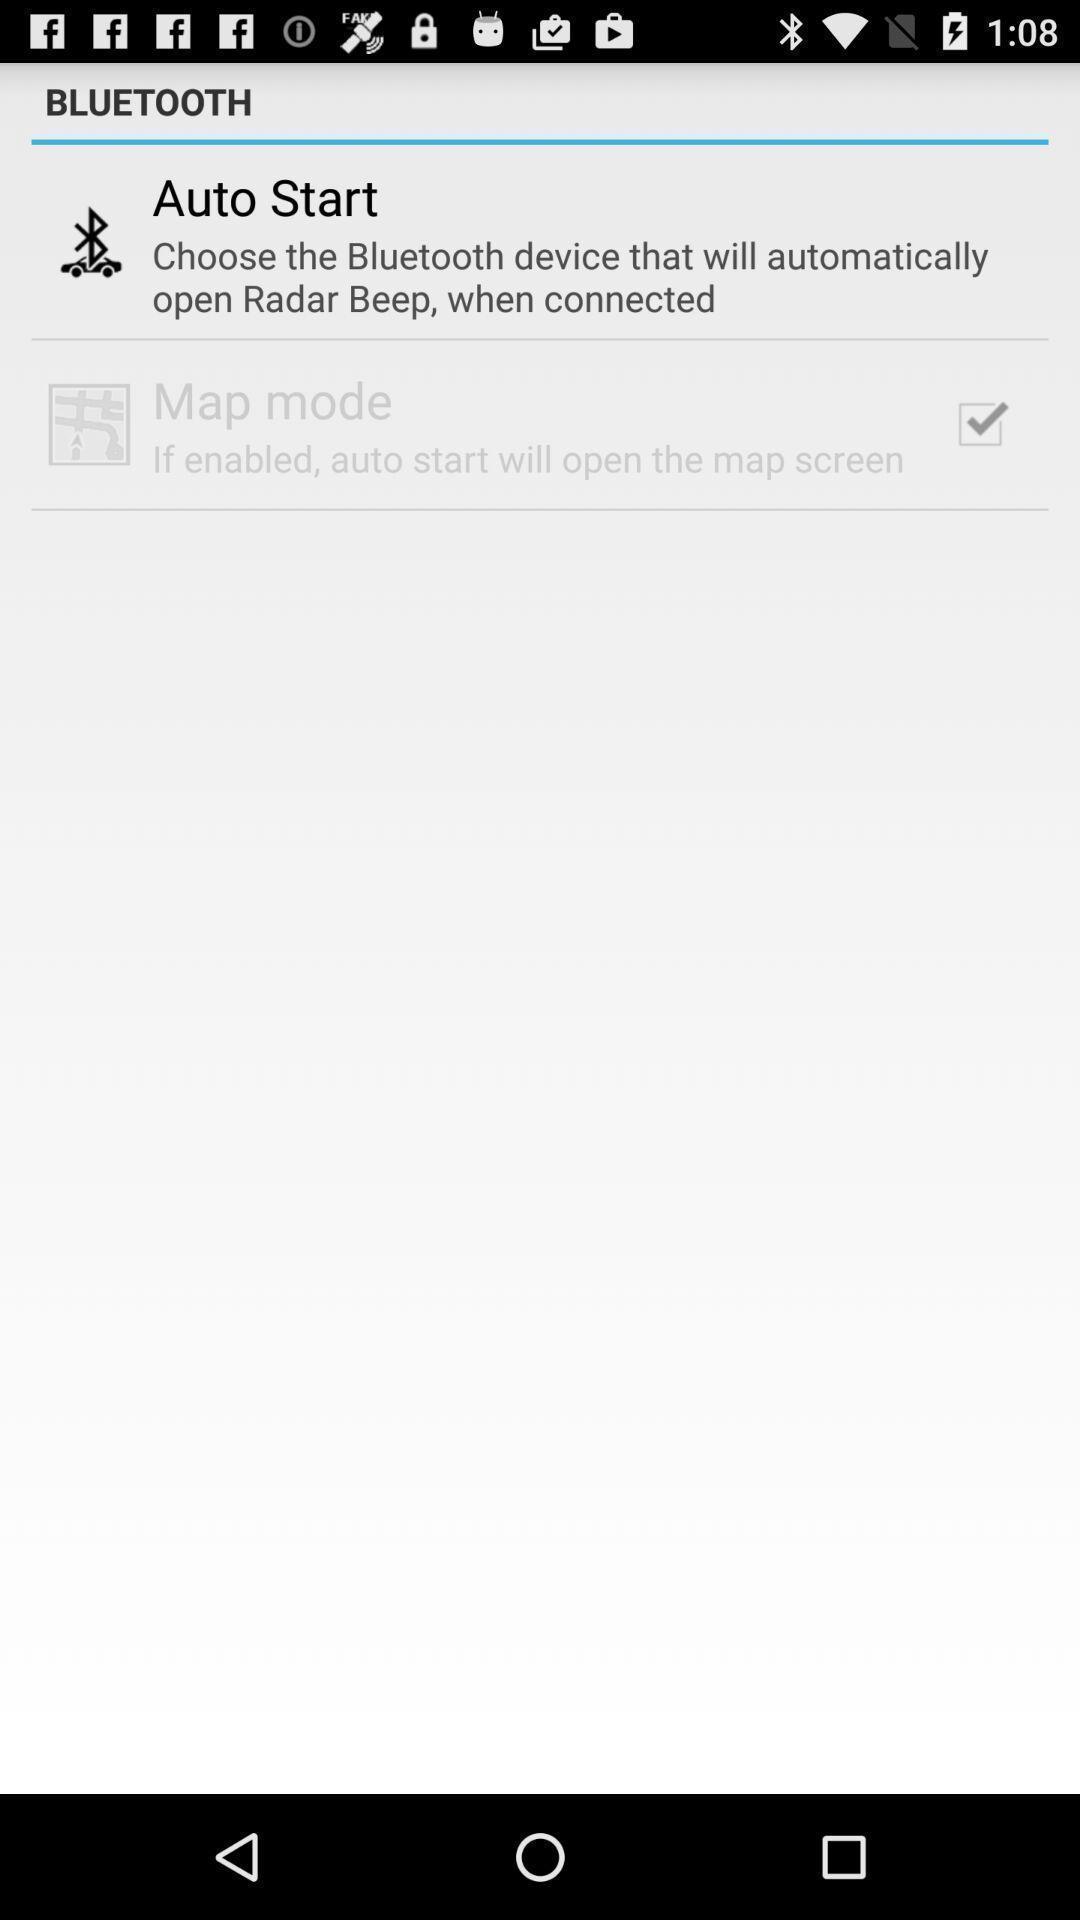Provide a detailed account of this screenshot. Settings page of the bluetooth. 